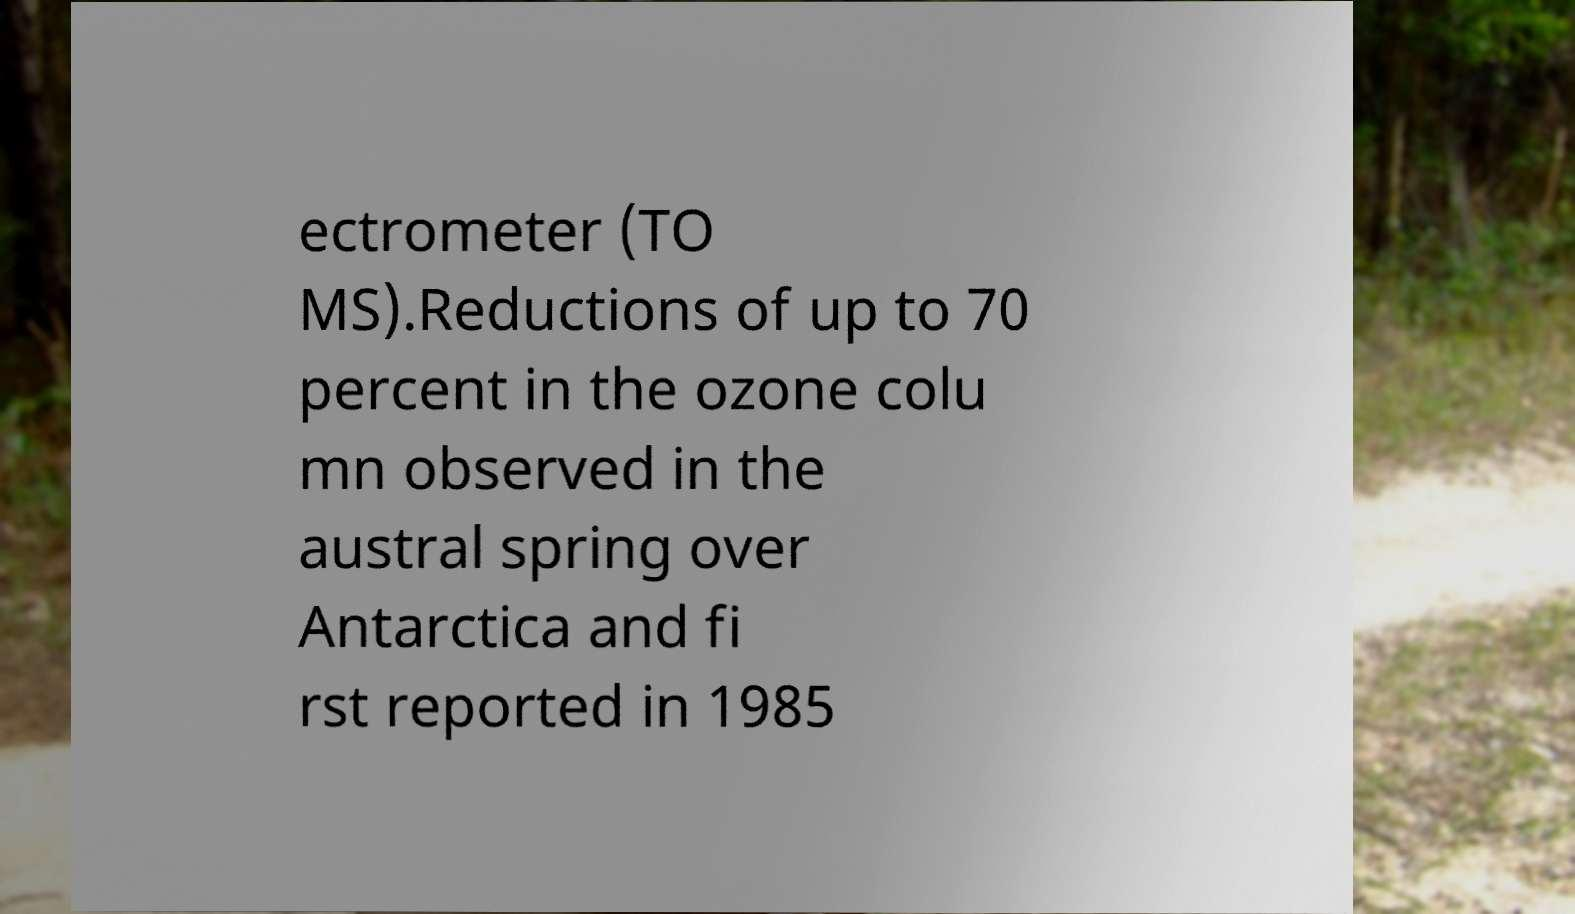Can you read and provide the text displayed in the image?This photo seems to have some interesting text. Can you extract and type it out for me? ectrometer (TO MS).Reductions of up to 70 percent in the ozone colu mn observed in the austral spring over Antarctica and fi rst reported in 1985 